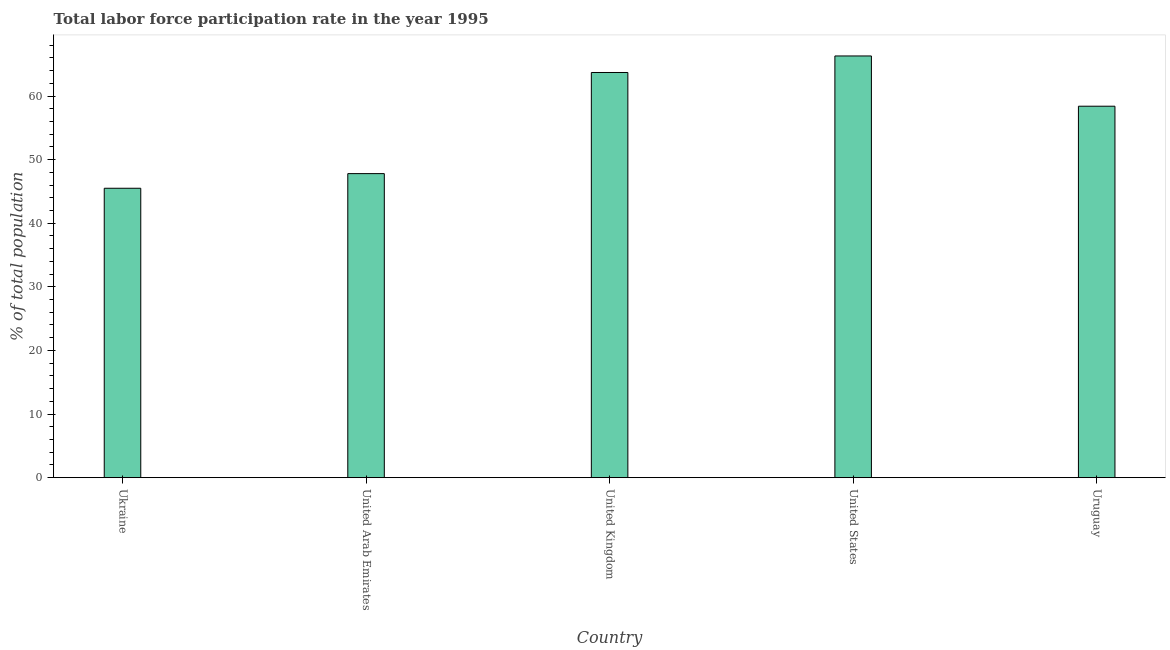Does the graph contain any zero values?
Your response must be concise. No. Does the graph contain grids?
Your response must be concise. No. What is the title of the graph?
Offer a terse response. Total labor force participation rate in the year 1995. What is the label or title of the X-axis?
Ensure brevity in your answer.  Country. What is the label or title of the Y-axis?
Offer a terse response. % of total population. What is the total labor force participation rate in United Kingdom?
Keep it short and to the point. 63.7. Across all countries, what is the maximum total labor force participation rate?
Ensure brevity in your answer.  66.3. Across all countries, what is the minimum total labor force participation rate?
Keep it short and to the point. 45.5. In which country was the total labor force participation rate minimum?
Offer a very short reply. Ukraine. What is the sum of the total labor force participation rate?
Your response must be concise. 281.7. What is the average total labor force participation rate per country?
Make the answer very short. 56.34. What is the median total labor force participation rate?
Give a very brief answer. 58.4. In how many countries, is the total labor force participation rate greater than 12 %?
Provide a short and direct response. 5. What is the ratio of the total labor force participation rate in Ukraine to that in United Kingdom?
Offer a very short reply. 0.71. What is the difference between the highest and the second highest total labor force participation rate?
Give a very brief answer. 2.6. Is the sum of the total labor force participation rate in Ukraine and United Arab Emirates greater than the maximum total labor force participation rate across all countries?
Your answer should be very brief. Yes. What is the difference between the highest and the lowest total labor force participation rate?
Your answer should be compact. 20.8. How many bars are there?
Provide a succinct answer. 5. What is the difference between two consecutive major ticks on the Y-axis?
Your answer should be compact. 10. What is the % of total population in Ukraine?
Your response must be concise. 45.5. What is the % of total population in United Arab Emirates?
Offer a very short reply. 47.8. What is the % of total population in United Kingdom?
Make the answer very short. 63.7. What is the % of total population of United States?
Provide a succinct answer. 66.3. What is the % of total population in Uruguay?
Keep it short and to the point. 58.4. What is the difference between the % of total population in Ukraine and United Arab Emirates?
Keep it short and to the point. -2.3. What is the difference between the % of total population in Ukraine and United Kingdom?
Your answer should be very brief. -18.2. What is the difference between the % of total population in Ukraine and United States?
Offer a very short reply. -20.8. What is the difference between the % of total population in Ukraine and Uruguay?
Make the answer very short. -12.9. What is the difference between the % of total population in United Arab Emirates and United Kingdom?
Offer a very short reply. -15.9. What is the difference between the % of total population in United Arab Emirates and United States?
Your answer should be very brief. -18.5. What is the difference between the % of total population in United Kingdom and United States?
Provide a short and direct response. -2.6. What is the difference between the % of total population in United Kingdom and Uruguay?
Provide a short and direct response. 5.3. What is the difference between the % of total population in United States and Uruguay?
Offer a terse response. 7.9. What is the ratio of the % of total population in Ukraine to that in United Kingdom?
Provide a short and direct response. 0.71. What is the ratio of the % of total population in Ukraine to that in United States?
Provide a succinct answer. 0.69. What is the ratio of the % of total population in Ukraine to that in Uruguay?
Your answer should be compact. 0.78. What is the ratio of the % of total population in United Arab Emirates to that in United States?
Give a very brief answer. 0.72. What is the ratio of the % of total population in United Arab Emirates to that in Uruguay?
Keep it short and to the point. 0.82. What is the ratio of the % of total population in United Kingdom to that in United States?
Your answer should be compact. 0.96. What is the ratio of the % of total population in United Kingdom to that in Uruguay?
Ensure brevity in your answer.  1.09. What is the ratio of the % of total population in United States to that in Uruguay?
Offer a very short reply. 1.14. 